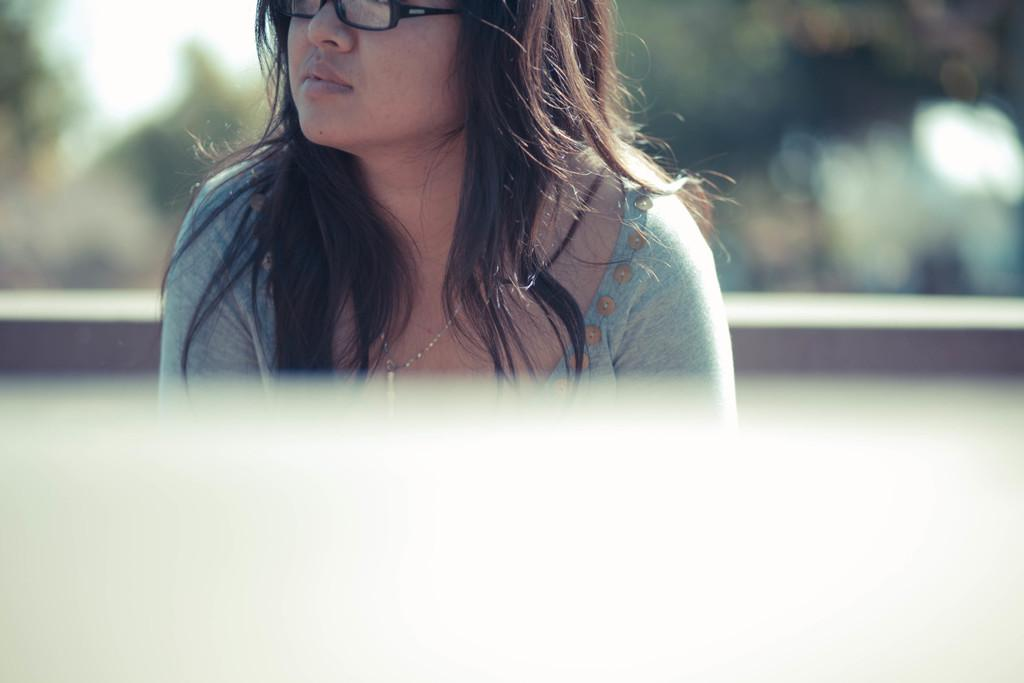Who is the main subject in the image? There is a woman in the image. What can be observed about the woman's appearance? The woman is wearing spectacles. Can you describe the background of the image? The background of the image is blurry. What type of needle is the woman using in the image? There is no needle present in the image. What nation does the woman represent in the image? The image does not provide any information about the woman's nationality or representation of a nation. 